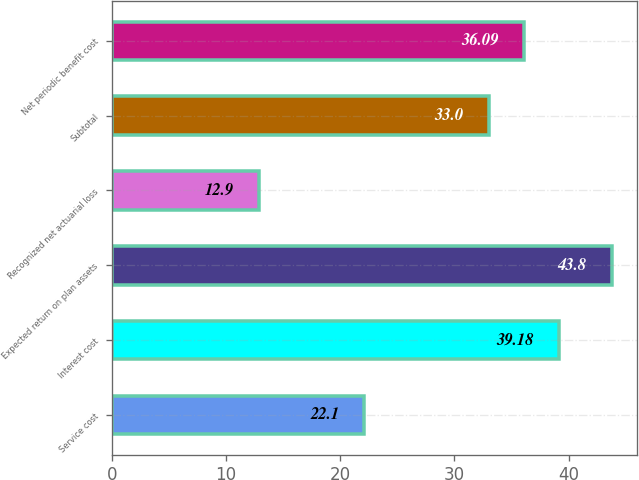Convert chart to OTSL. <chart><loc_0><loc_0><loc_500><loc_500><bar_chart><fcel>Service cost<fcel>Interest cost<fcel>Expected return on plan assets<fcel>Recognized net actuarial loss<fcel>Subtotal<fcel>Net periodic benefit cost<nl><fcel>22.1<fcel>39.18<fcel>43.8<fcel>12.9<fcel>33<fcel>36.09<nl></chart> 